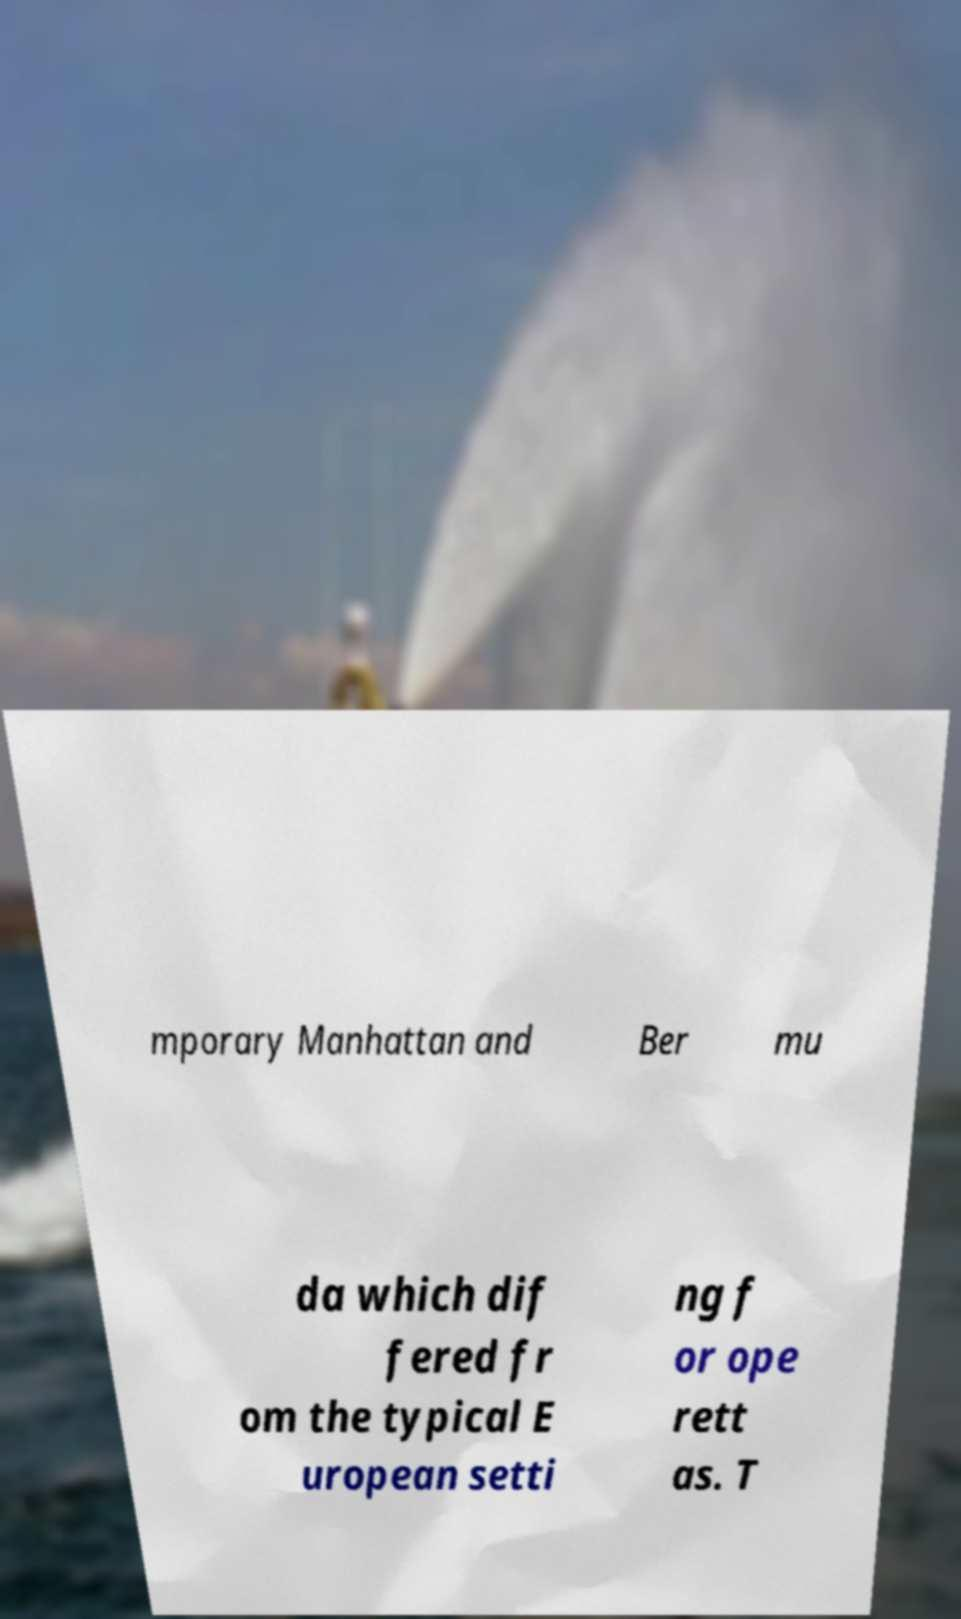Can you read and provide the text displayed in the image?This photo seems to have some interesting text. Can you extract and type it out for me? mporary Manhattan and Ber mu da which dif fered fr om the typical E uropean setti ng f or ope rett as. T 